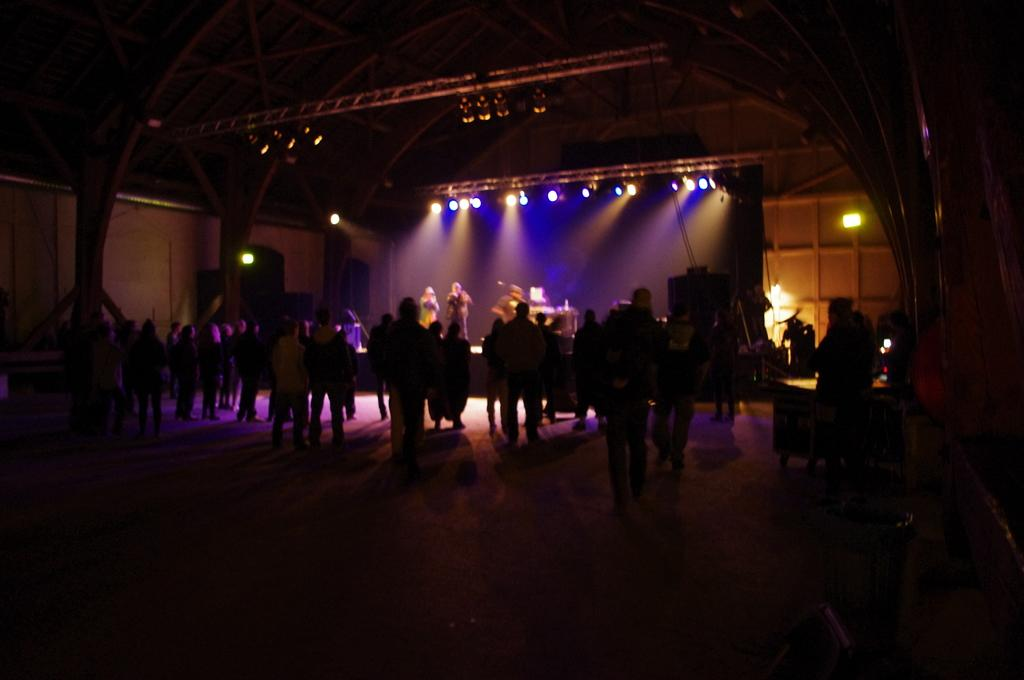How many people are in the image? There is a group of people in the image, but the exact number is not specified. What is the position of the people in the image? The people are on the ground in the image. What can be seen in the background of the image? There is a wall, lights, a roof, and some objects in the background of the image. Can you hear the nut sneezing in the image? There is no nut or sneezing present in the image; it features a group of people on the ground with a background containing a wall, lights, a roof, and other objects. 